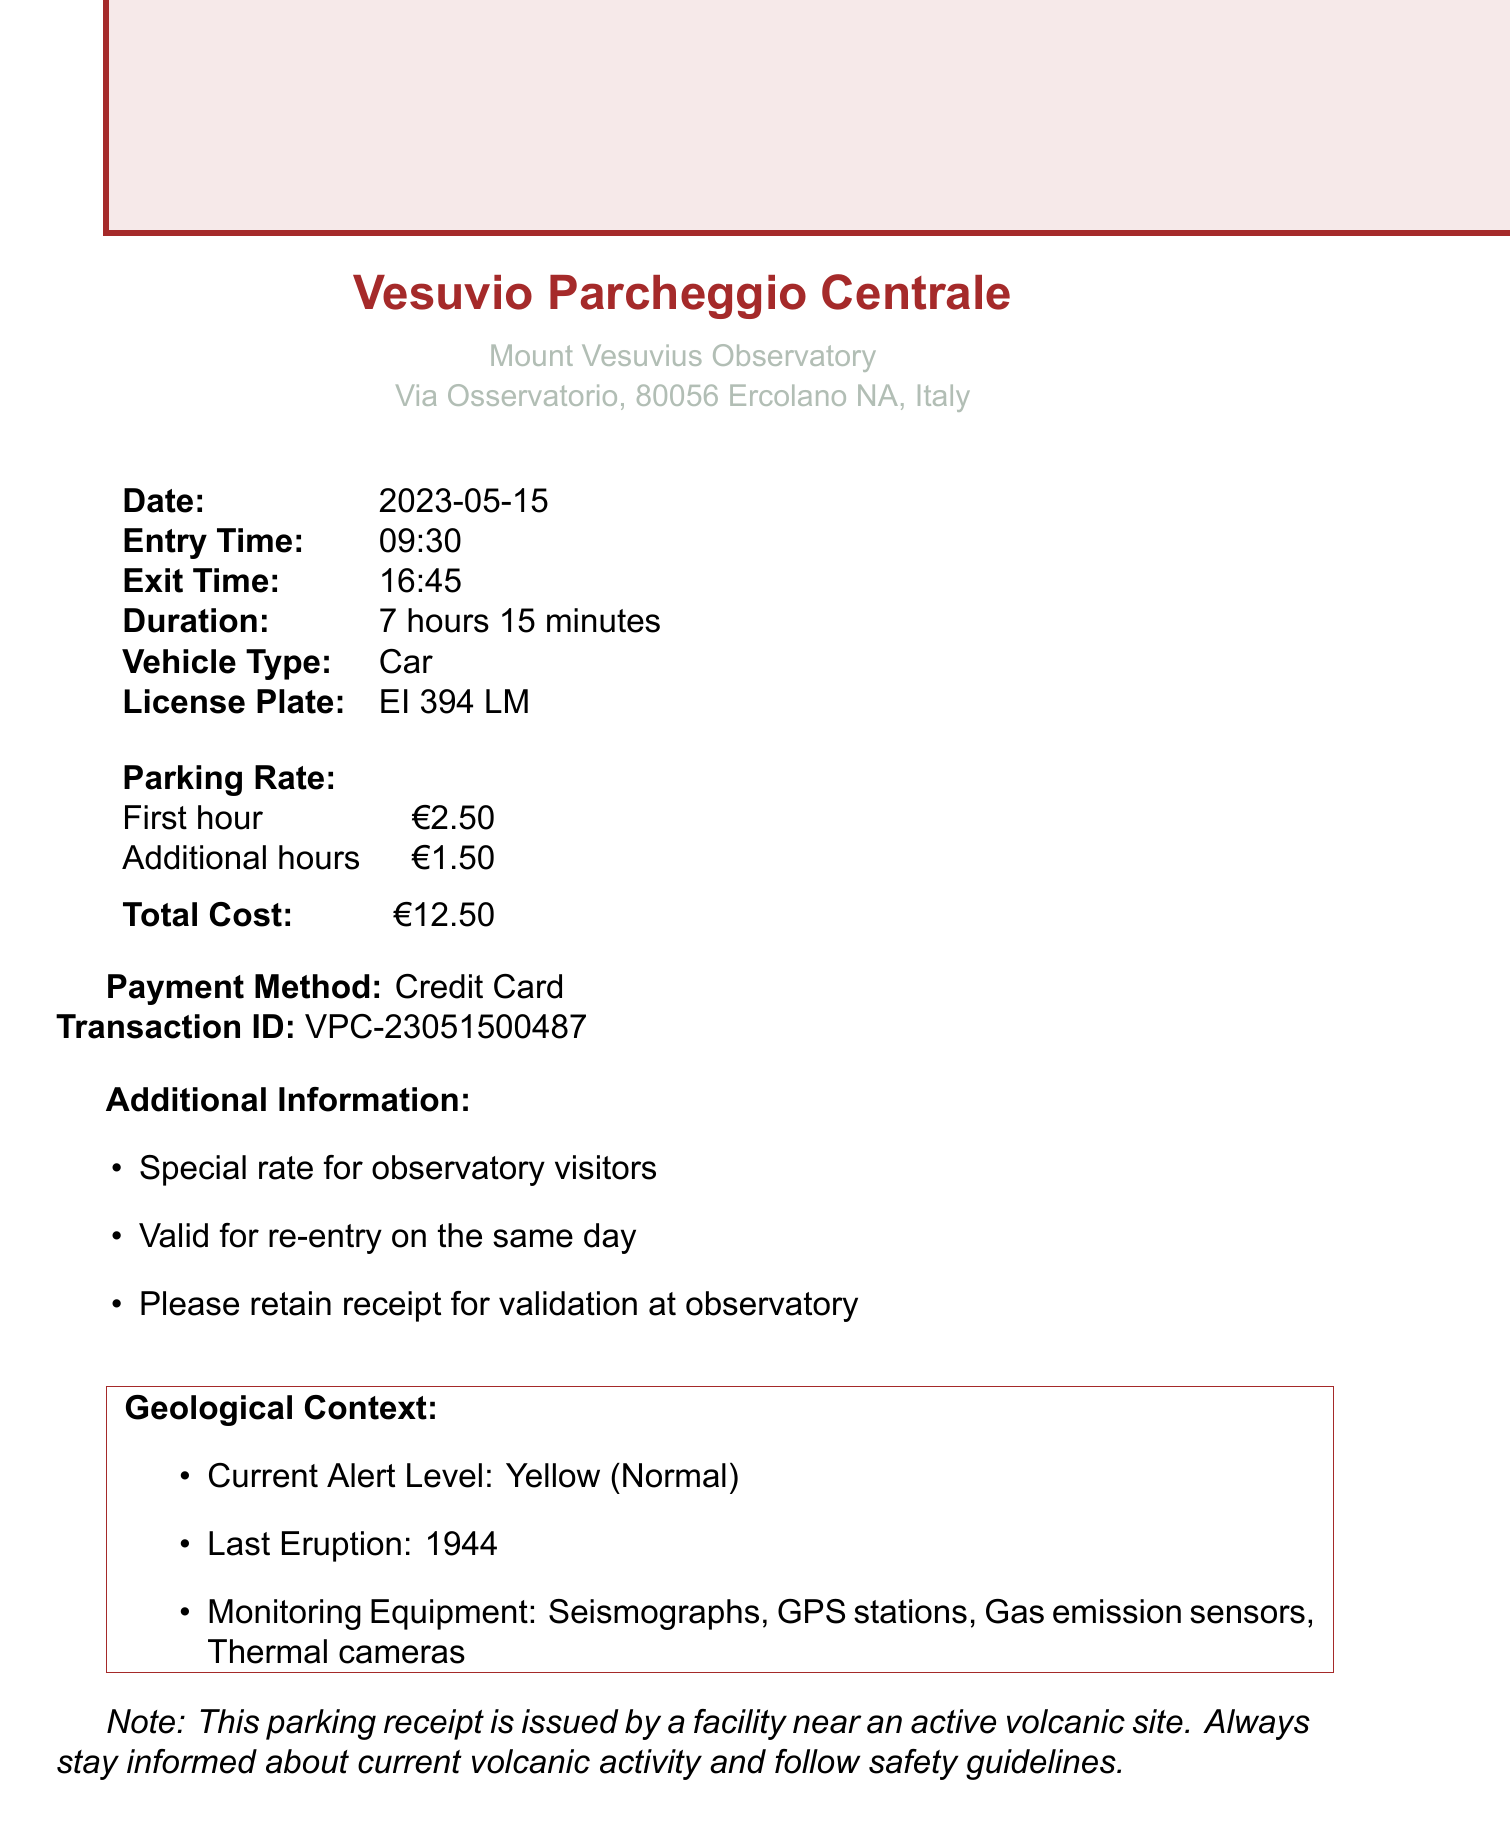What is the name of the parking garage? The name of the parking garage is explicitly stated in the document.
Answer: Vesuvio Parcheggio Centrale What is the duration of the stay? The duration is detailed in the document, specifying the total time parked.
Answer: 7 hours 15 minutes What was the total cost of parking? The document includes the total amount charged for parking services.
Answer: €12.50 What is the entry time? The entry time is specifically listed in the receipt details.
Answer: 09:30 What is the current alert level for the volcano? The document provides geological context, including the alert level.
Answer: Yellow (Normal) What payment method was used? The payment method is mentioned in the receipt.
Answer: Credit Card How many monitoring equipment types are listed? This number can be deduced by counting the items in the monitoring equipment section.
Answer: 4 What was observed during the visit? The professor notes provide insights into activities undertaken during the visit.
Answer: Increased fumarolic activity What is the last eruption date of the volcano? The document mentions the last eruption date within the geological context.
Answer: 1944 Is there a re-entry policy mentioned? Additional information includes special conditions related to vehicle re-entry.
Answer: Yes, valid for re-entry on the same day 